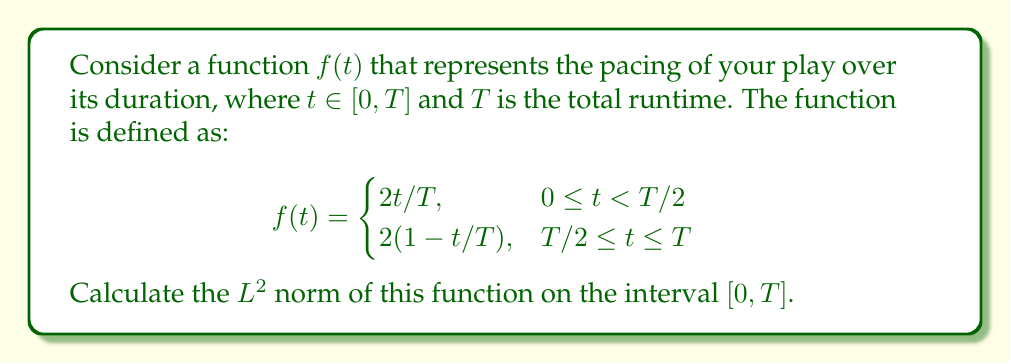Show me your answer to this math problem. To calculate the $L^2$ norm of the function $f(t)$, we need to compute:

$$\|f\|_2 = \left(\int_0^T |f(t)|^2 dt\right)^{1/2}$$

Let's break this down into steps:

1) First, we split the integral into two parts due to the piecewise definition of $f(t)$:

   $$\|f\|_2^2 = \int_0^{T/2} \left(\frac{2t}{T}\right)^2 dt + \int_{T/2}^T \left(2\left(1-\frac{t}{T}\right)\right)^2 dt$$

2) Let's evaluate the first integral:

   $$\int_0^{T/2} \left(\frac{2t}{T}\right)^2 dt = \frac{4}{T^2} \int_0^{T/2} t^2 dt = \frac{4}{T^2} \left[\frac{t^3}{3}\right]_0^{T/2} = \frac{4}{T^2} \cdot \frac{(T/2)^3}{3} = \frac{T}{6}$$

3) Now for the second integral:

   $$\int_{T/2}^T \left(2\left(1-\frac{t}{T}\right)\right)^2 dt = 4 \int_{T/2}^T \left(1-\frac{2t}{T}+\frac{t^2}{T^2}\right) dt$$

   $$= 4 \left[t - \frac{t^2}{T} + \frac{t^3}{3T^2}\right]_{T/2}^T = 4 \left[\left(T - T + \frac{T}{3}\right) - \left(\frac{T}{2} - \frac{T}{4} + \frac{T}{24}\right)\right] = \frac{T}{6}$$

4) Adding the results from steps 2 and 3:

   $$\|f\|_2^2 = \frac{T}{6} + \frac{T}{6} = \frac{T}{3}$$

5) Taking the square root:

   $$\|f\|_2 = \sqrt{\frac{T}{3}}$$

This result represents the $L^2$ norm of the pacing function for your play.
Answer: $$\|f\|_2 = \sqrt{\frac{T}{3}}$$ 